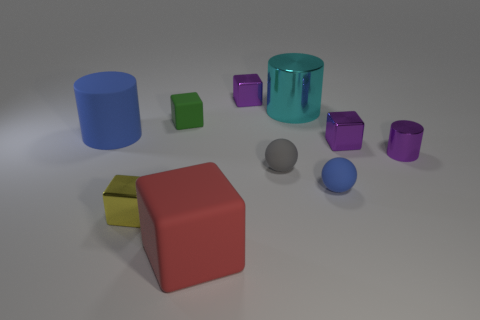Subtract all shiny cylinders. How many cylinders are left? 1 Subtract all gray balls. How many balls are left? 1 Subtract all balls. How many objects are left? 8 Subtract all gray cylinders. Subtract all brown spheres. How many cylinders are left? 3 Subtract all green cubes. How many purple cylinders are left? 1 Subtract all yellow matte things. Subtract all big metallic things. How many objects are left? 9 Add 9 matte cylinders. How many matte cylinders are left? 10 Add 5 cyan cubes. How many cyan cubes exist? 5 Subtract 0 green spheres. How many objects are left? 10 Subtract 3 cylinders. How many cylinders are left? 0 